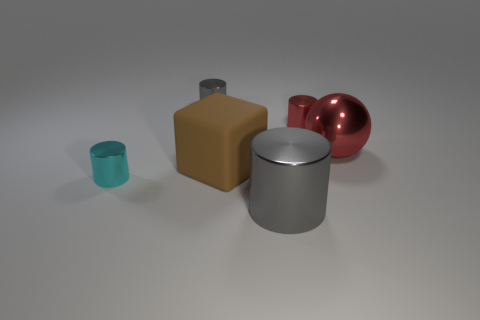Is there anything else that has the same material as the big brown block? Based on the image, it appears that the cylindrical object next to the big brown block shares a similar polished surface quality and reflection characteristics, suggesting they may be made from the same or similar material. 